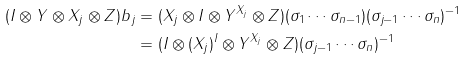Convert formula to latex. <formula><loc_0><loc_0><loc_500><loc_500>( I \otimes Y \otimes X _ { j } \otimes Z ) b _ { j } & = ( X _ { j } \otimes I \otimes Y ^ { X _ { j } } \otimes Z ) ( \sigma _ { 1 } \cdots \sigma _ { n - 1 } ) ( \sigma _ { j - 1 } \cdots \sigma _ { n } ) ^ { - 1 } \\ & = ( I \otimes ( X _ { j } ) ^ { I } \otimes Y ^ { X _ { j } } \otimes Z ) ( \sigma _ { j - 1 } \cdots \sigma _ { n } ) ^ { - 1 }</formula> 